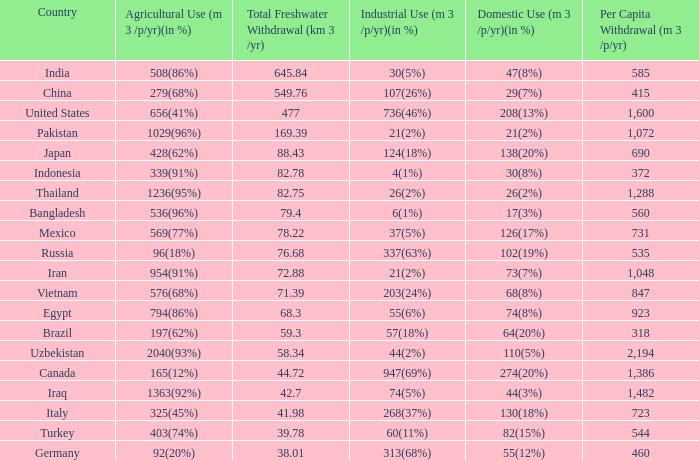What is Agricultural Use (m 3 /p/yr)(in %), when Per Capita Withdrawal (m 3 /p/yr) is greater than 923, and when Domestic Use (m 3 /p/yr)(in %) is 73(7%)? 954(91%). 